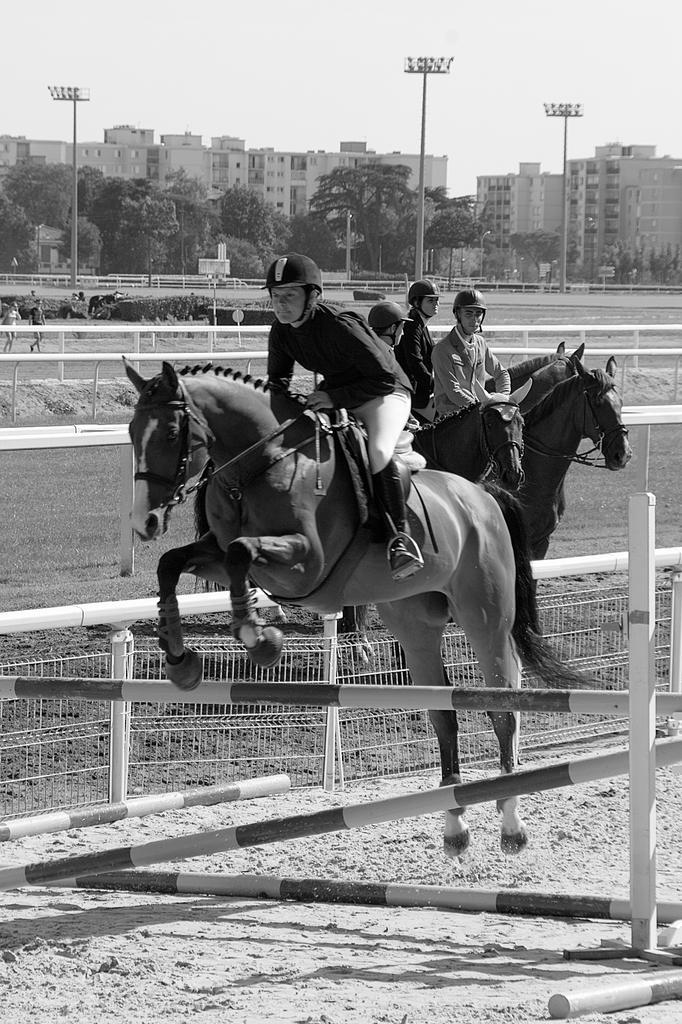Describe this image in one or two sentences. Here there are group of horses, persons sitting on each of them the horse here is jumping through a pole and behind there are buildings, there are light poles, there are trees. Sky is clear, these people are wearing helmets 